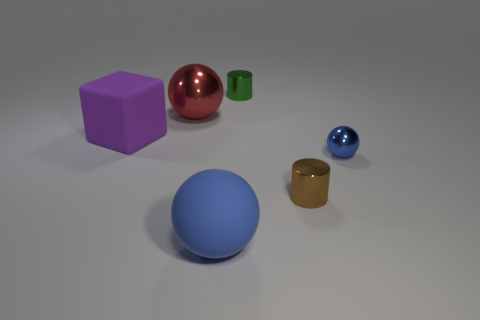Add 4 shiny balls. How many objects exist? 10 Subtract all cubes. How many objects are left? 5 Add 1 blue spheres. How many blue spheres exist? 3 Subtract 0 yellow spheres. How many objects are left? 6 Subtract all big purple blocks. Subtract all big blue rubber balls. How many objects are left? 4 Add 3 tiny spheres. How many tiny spheres are left? 4 